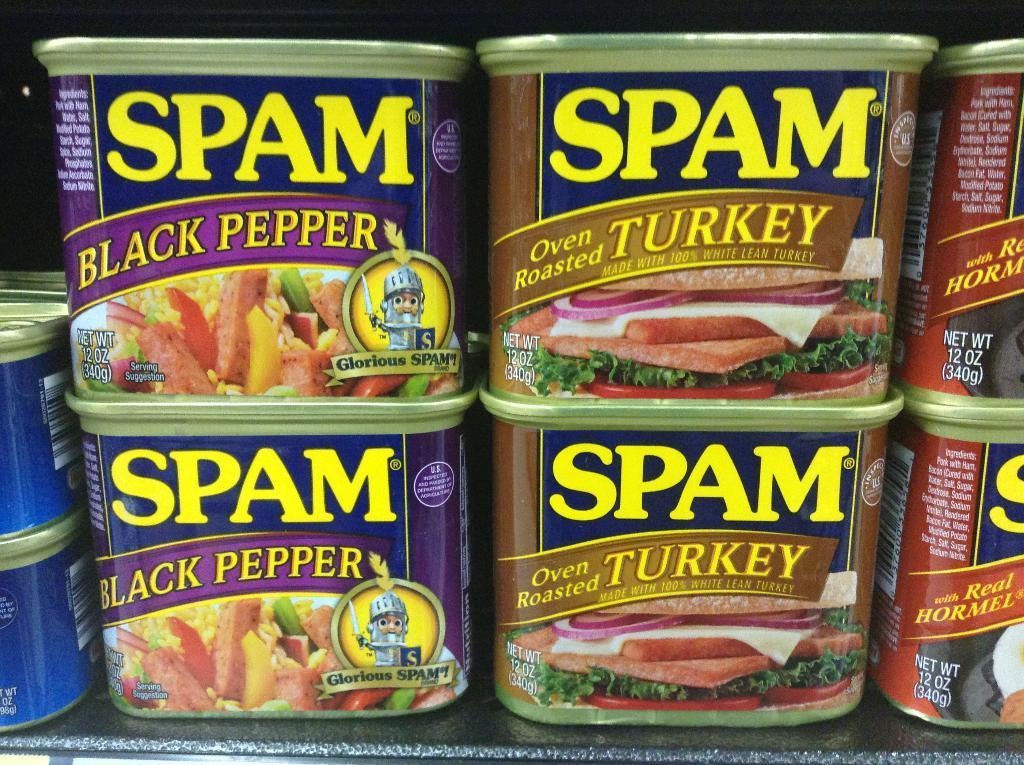In one or two sentences, can you explain what this image depicts? In this picture we can see some boxes with labels on the platform. 